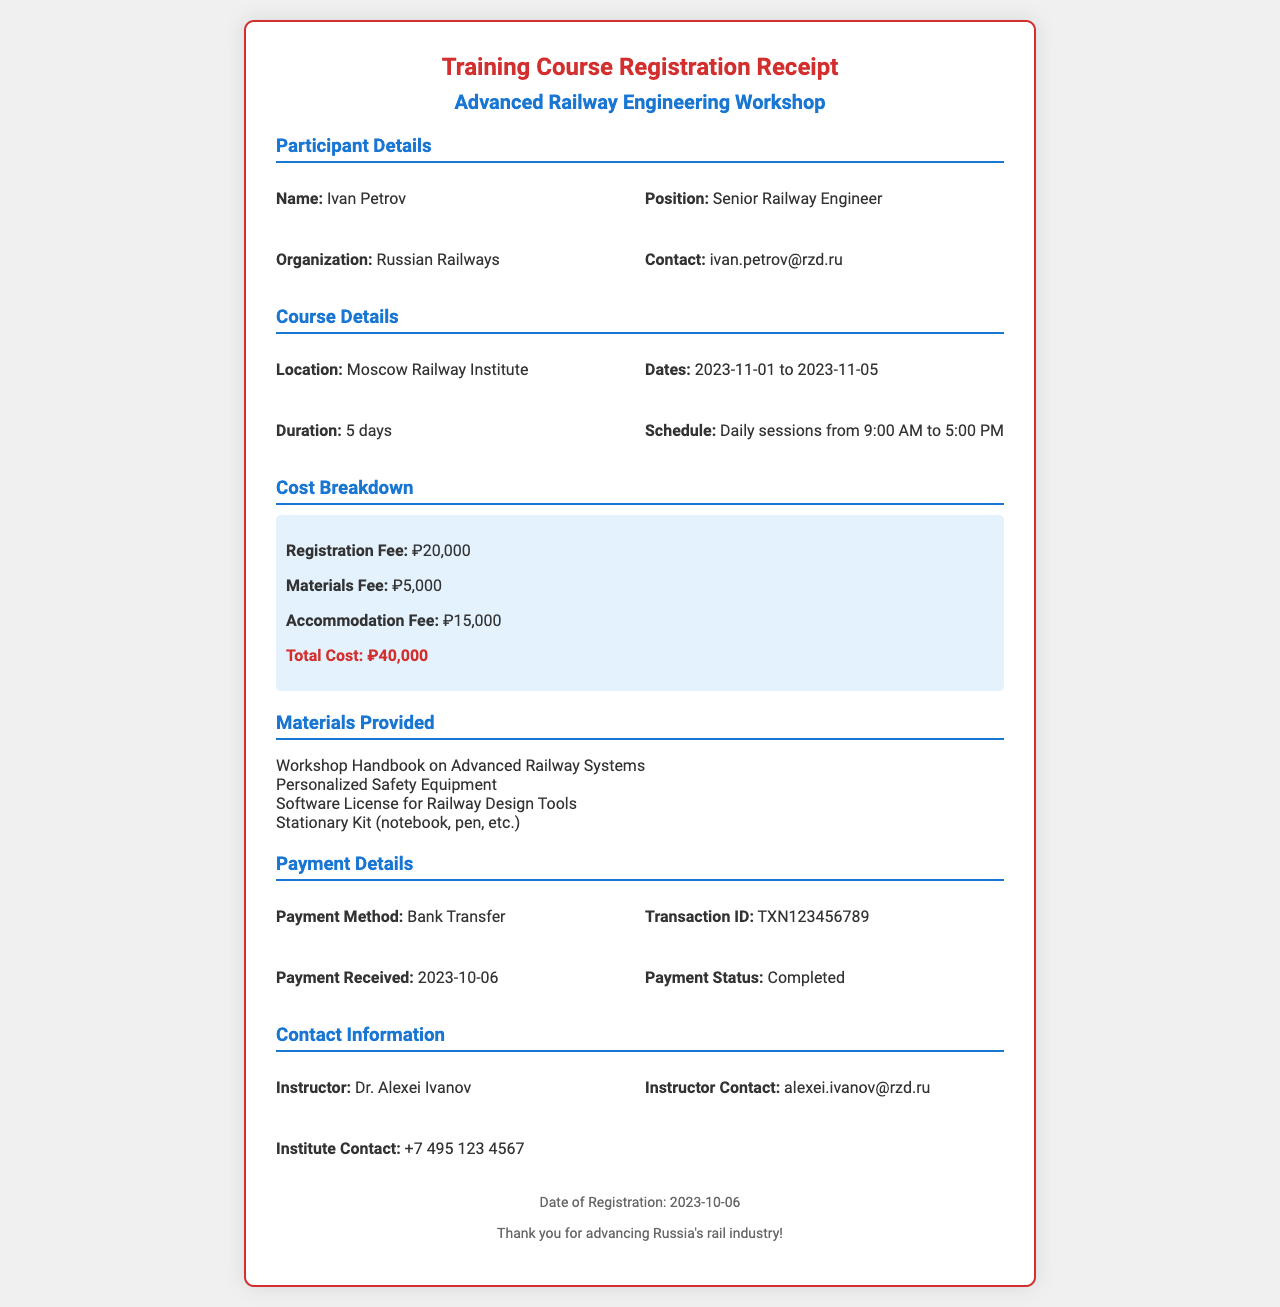What is the name of the participant? The name of the participant is provided in the document.
Answer: Ivan Petrov What is the location of the workshop? The location of the workshop is specified in the document.
Answer: Moscow Railway Institute What is the registration fee? The registration fee is itemized in the cost breakdown section of the document.
Answer: ₽20,000 How many days does the workshop last? The duration of the workshop is mentioned in the course details.
Answer: 5 days What is the total cost of the workshop? The total cost is calculated from the cost breakdown items in the document.
Answer: ₽40,000 What materials are provided? The materials list is detailed in the corresponding section of the document.
Answer: Workshop Handbook on Advanced Railway Systems What is the payment method used? The payment method used for the registration is stated in the payment details section.
Answer: Bank Transfer What is the payment status? The payment status indicates whether the payment has been finalized in the document.
Answer: Completed Who is the instructor for the course? The instructor's name is listed in the contact information section of the document.
Answer: Dr. Alexei Ivanov 